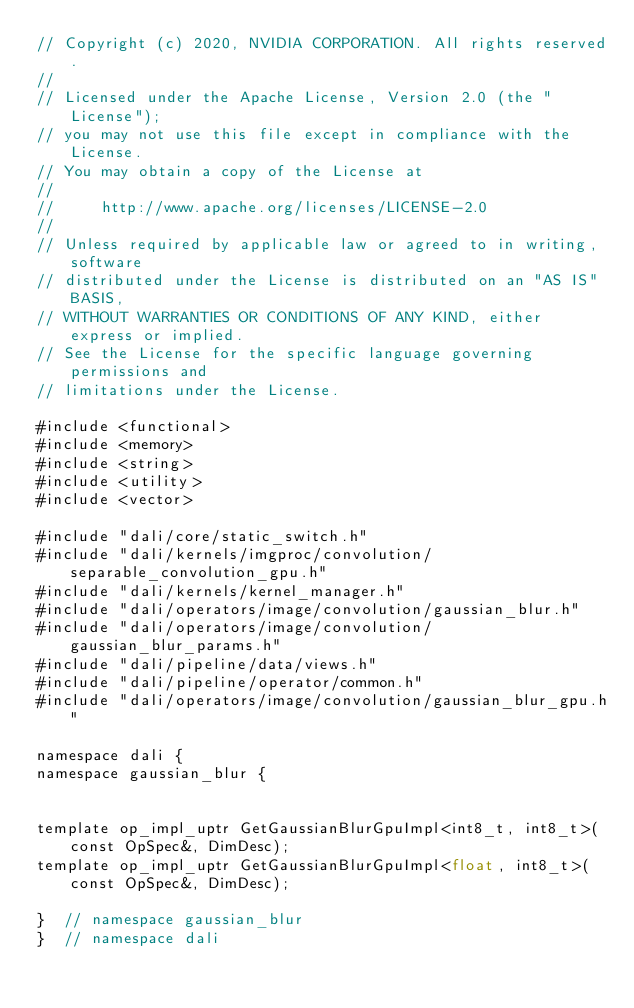<code> <loc_0><loc_0><loc_500><loc_500><_Cuda_>// Copyright (c) 2020, NVIDIA CORPORATION. All rights reserved.
//
// Licensed under the Apache License, Version 2.0 (the "License");
// you may not use this file except in compliance with the License.
// You may obtain a copy of the License at
//
//     http://www.apache.org/licenses/LICENSE-2.0
//
// Unless required by applicable law or agreed to in writing, software
// distributed under the License is distributed on an "AS IS" BASIS,
// WITHOUT WARRANTIES OR CONDITIONS OF ANY KIND, either express or implied.
// See the License for the specific language governing permissions and
// limitations under the License.

#include <functional>
#include <memory>
#include <string>
#include <utility>
#include <vector>

#include "dali/core/static_switch.h"
#include "dali/kernels/imgproc/convolution/separable_convolution_gpu.h"
#include "dali/kernels/kernel_manager.h"
#include "dali/operators/image/convolution/gaussian_blur.h"
#include "dali/operators/image/convolution/gaussian_blur_params.h"
#include "dali/pipeline/data/views.h"
#include "dali/pipeline/operator/common.h"
#include "dali/operators/image/convolution/gaussian_blur_gpu.h"

namespace dali {
namespace gaussian_blur {


template op_impl_uptr GetGaussianBlurGpuImpl<int8_t, int8_t>(const OpSpec&, DimDesc);
template op_impl_uptr GetGaussianBlurGpuImpl<float, int8_t>(const OpSpec&, DimDesc);

}  // namespace gaussian_blur
}  // namespace dali
</code> 